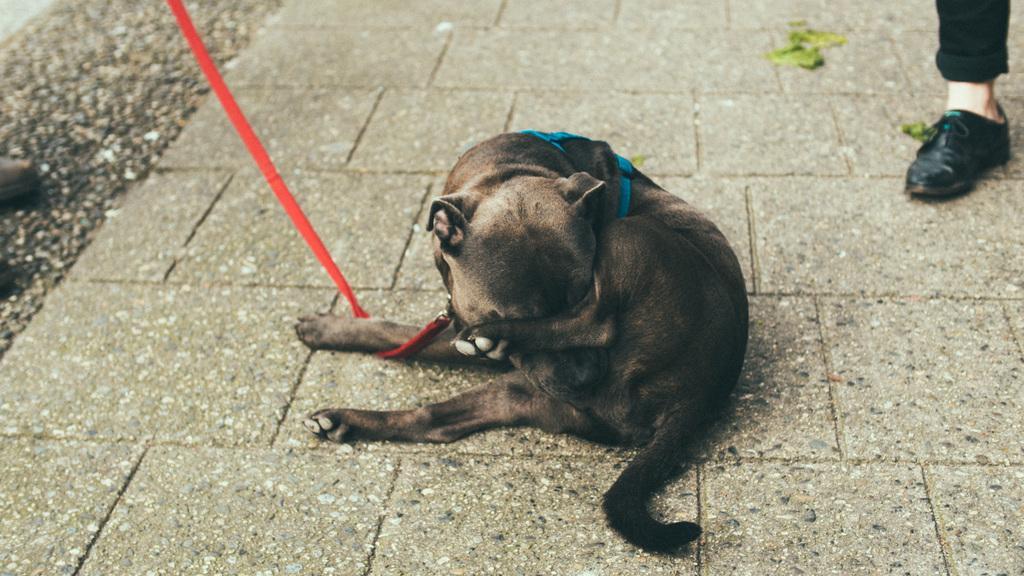Could you give a brief overview of what you see in this image? In this image there is an animal sitting on the floor. The animal is tied with a belt. Right to a person's leg is visible. 